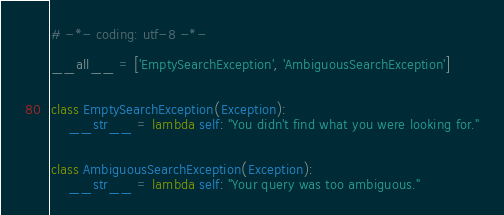Convert code to text. <code><loc_0><loc_0><loc_500><loc_500><_Python_># -*- coding: utf-8 -*-

__all__ = ['EmptySearchException', 'AmbiguousSearchException']


class EmptySearchException(Exception):
    __str__ = lambda self: "You didn't find what you were looking for."


class AmbiguousSearchException(Exception):
    __str__ = lambda self: "Your query was too ambiguous."
</code> 